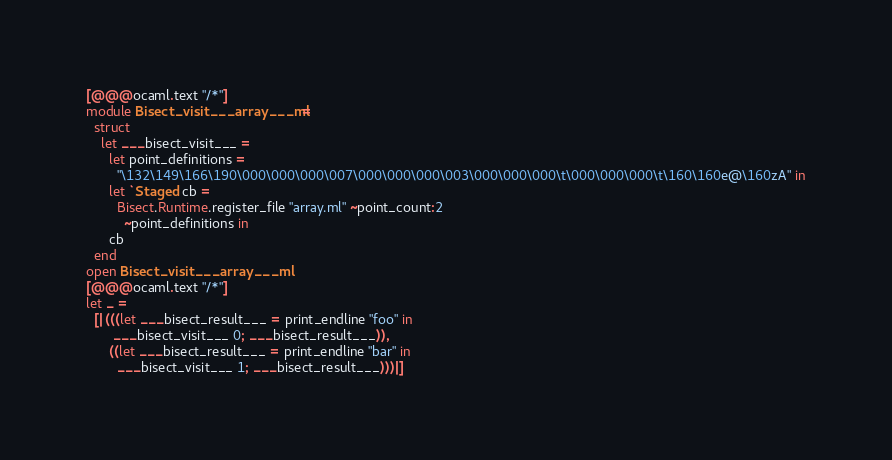<code> <loc_0><loc_0><loc_500><loc_500><_OCaml_>[@@@ocaml.text "/*"]
module Bisect_visit___array___ml =
  struct
    let ___bisect_visit___ =
      let point_definitions =
        "\132\149\166\190\000\000\000\007\000\000\000\003\000\000\000\t\000\000\000\t\160\160e@\160zA" in
      let `Staged cb =
        Bisect.Runtime.register_file "array.ml" ~point_count:2
          ~point_definitions in
      cb
  end
open Bisect_visit___array___ml
[@@@ocaml.text "/*"]
let _ =
  [|(((let ___bisect_result___ = print_endline "foo" in
       ___bisect_visit___ 0; ___bisect_result___)),
      ((let ___bisect_result___ = print_endline "bar" in
        ___bisect_visit___ 1; ___bisect_result___)))|]
</code> 